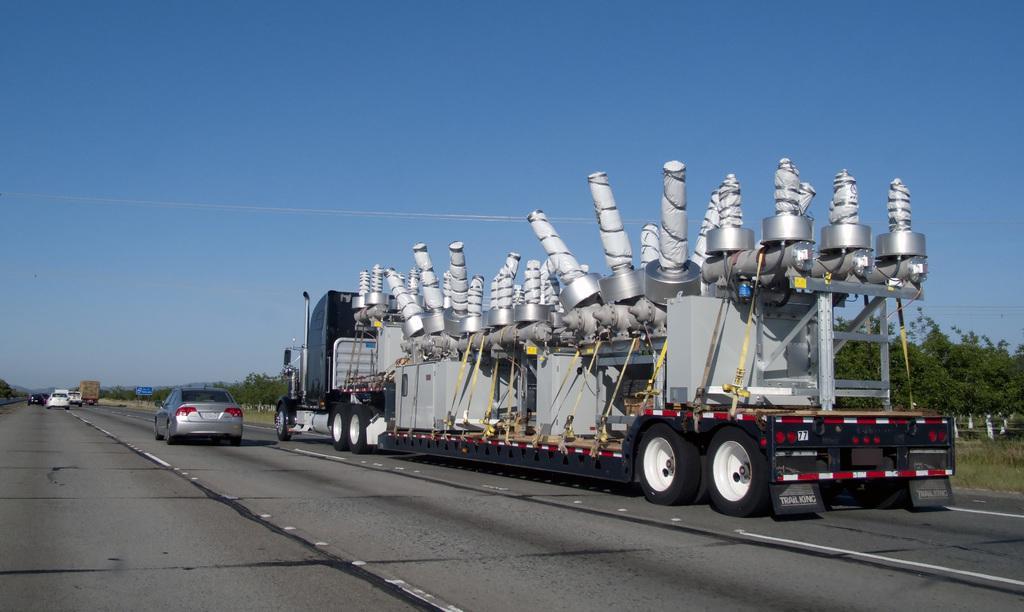Please provide a concise description of this image. In this picture I can observe a vehicle moving on the road. I can observe some cars on the road. In the background there are trees and sky. 